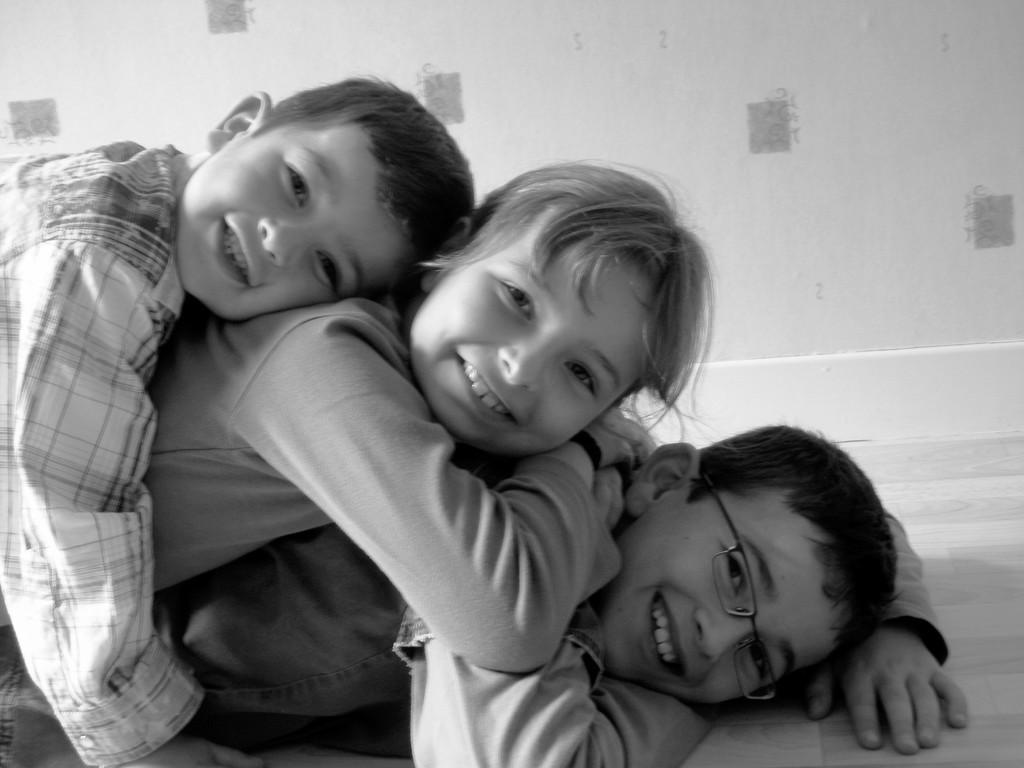How would you summarize this image in a sentence or two? This is a black and white picture. In this picture, we see two boys and a girl are lying. They are smiling and they are posing for the photo. The boy at the bottom is wearing the spectacles. In the background, we see a wall in white color. At the bottom, we see the floor. 